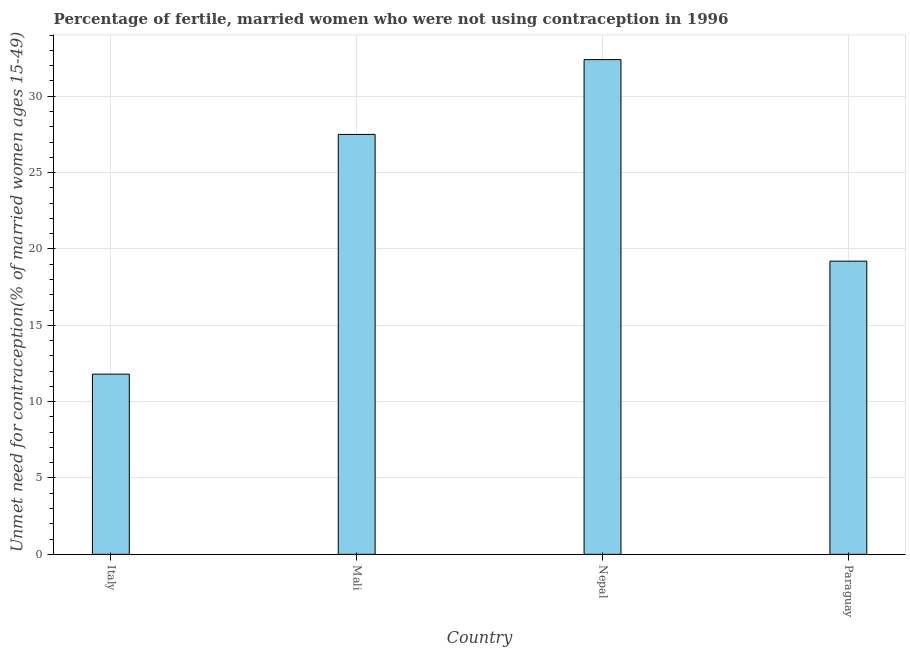What is the title of the graph?
Make the answer very short. Percentage of fertile, married women who were not using contraception in 1996. What is the label or title of the Y-axis?
Your response must be concise.  Unmet need for contraception(% of married women ages 15-49). What is the number of married women who are not using contraception in Paraguay?
Ensure brevity in your answer.  19.2. Across all countries, what is the maximum number of married women who are not using contraception?
Provide a succinct answer. 32.4. Across all countries, what is the minimum number of married women who are not using contraception?
Make the answer very short. 11.8. In which country was the number of married women who are not using contraception maximum?
Offer a terse response. Nepal. What is the sum of the number of married women who are not using contraception?
Keep it short and to the point. 90.9. What is the difference between the number of married women who are not using contraception in Mali and Paraguay?
Ensure brevity in your answer.  8.3. What is the average number of married women who are not using contraception per country?
Your answer should be compact. 22.73. What is the median number of married women who are not using contraception?
Your answer should be compact. 23.35. In how many countries, is the number of married women who are not using contraception greater than 25 %?
Your answer should be compact. 2. What is the ratio of the number of married women who are not using contraception in Italy to that in Mali?
Your response must be concise. 0.43. Is the number of married women who are not using contraception in Mali less than that in Nepal?
Ensure brevity in your answer.  Yes. What is the difference between the highest and the second highest number of married women who are not using contraception?
Your answer should be very brief. 4.9. Is the sum of the number of married women who are not using contraception in Mali and Nepal greater than the maximum number of married women who are not using contraception across all countries?
Offer a terse response. Yes. What is the difference between the highest and the lowest number of married women who are not using contraception?
Keep it short and to the point. 20.6. In how many countries, is the number of married women who are not using contraception greater than the average number of married women who are not using contraception taken over all countries?
Your answer should be very brief. 2. How many bars are there?
Offer a very short reply. 4. Are all the bars in the graph horizontal?
Your response must be concise. No. How many countries are there in the graph?
Your answer should be compact. 4. What is the difference between two consecutive major ticks on the Y-axis?
Provide a succinct answer. 5. Are the values on the major ticks of Y-axis written in scientific E-notation?
Offer a terse response. No. What is the  Unmet need for contraception(% of married women ages 15-49) in Nepal?
Offer a very short reply. 32.4. What is the difference between the  Unmet need for contraception(% of married women ages 15-49) in Italy and Mali?
Keep it short and to the point. -15.7. What is the difference between the  Unmet need for contraception(% of married women ages 15-49) in Italy and Nepal?
Your answer should be very brief. -20.6. What is the difference between the  Unmet need for contraception(% of married women ages 15-49) in Mali and Paraguay?
Keep it short and to the point. 8.3. What is the difference between the  Unmet need for contraception(% of married women ages 15-49) in Nepal and Paraguay?
Offer a very short reply. 13.2. What is the ratio of the  Unmet need for contraception(% of married women ages 15-49) in Italy to that in Mali?
Provide a succinct answer. 0.43. What is the ratio of the  Unmet need for contraception(% of married women ages 15-49) in Italy to that in Nepal?
Your answer should be compact. 0.36. What is the ratio of the  Unmet need for contraception(% of married women ages 15-49) in Italy to that in Paraguay?
Your answer should be compact. 0.61. What is the ratio of the  Unmet need for contraception(% of married women ages 15-49) in Mali to that in Nepal?
Your response must be concise. 0.85. What is the ratio of the  Unmet need for contraception(% of married women ages 15-49) in Mali to that in Paraguay?
Your answer should be very brief. 1.43. What is the ratio of the  Unmet need for contraception(% of married women ages 15-49) in Nepal to that in Paraguay?
Make the answer very short. 1.69. 